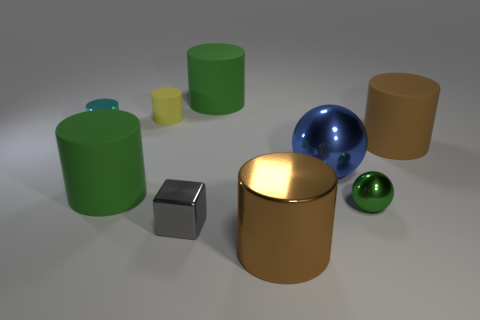What number of other things are there of the same color as the small ball?
Your answer should be very brief. 2. There is a large rubber thing that is behind the small yellow matte cylinder; are there any small objects that are right of it?
Keep it short and to the point. Yes. What color is the other tiny thing that is the same shape as the tiny cyan metallic thing?
Your answer should be very brief. Yellow. Is the color of the metal cylinder that is to the right of the small cyan metallic cylinder the same as the small block?
Offer a very short reply. No. How many things are matte things that are behind the tiny cyan metal cylinder or purple metallic blocks?
Your answer should be compact. 2. What material is the large cylinder that is in front of the big green object in front of the large green rubber object right of the small yellow cylinder?
Offer a terse response. Metal. Are there more shiny cylinders on the right side of the yellow rubber object than gray metal cubes in front of the small gray cube?
Offer a terse response. Yes. What number of balls are large purple things or green objects?
Your answer should be very brief. 1. There is a green cylinder behind the big green rubber cylinder in front of the cyan thing; what number of shiny objects are left of it?
Make the answer very short. 2. What is the material of the other cylinder that is the same color as the large metal cylinder?
Offer a very short reply. Rubber. 